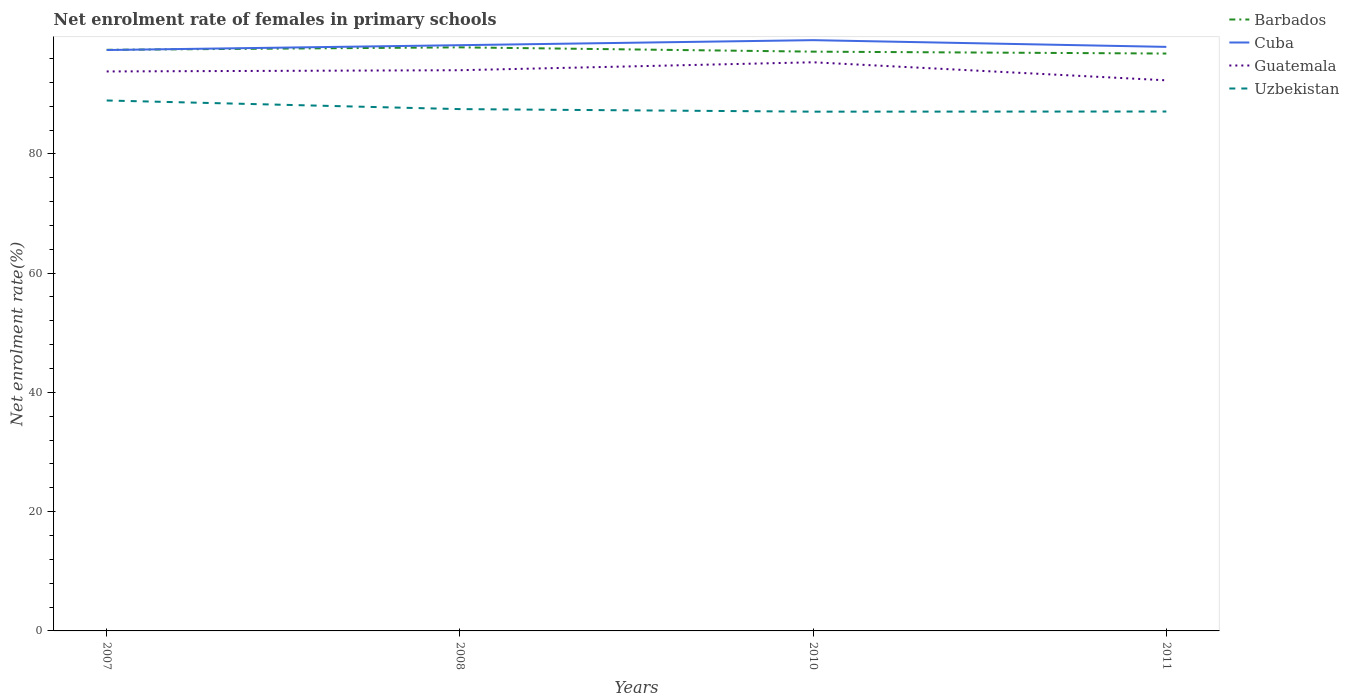Is the number of lines equal to the number of legend labels?
Your answer should be very brief. Yes. Across all years, what is the maximum net enrolment rate of females in primary schools in Cuba?
Provide a succinct answer. 97.42. What is the total net enrolment rate of females in primary schools in Guatemala in the graph?
Keep it short and to the point. -1.54. What is the difference between the highest and the second highest net enrolment rate of females in primary schools in Uzbekistan?
Make the answer very short. 1.87. What is the difference between the highest and the lowest net enrolment rate of females in primary schools in Cuba?
Offer a terse response. 2. Are the values on the major ticks of Y-axis written in scientific E-notation?
Your answer should be compact. No. Does the graph contain any zero values?
Give a very brief answer. No. Where does the legend appear in the graph?
Your response must be concise. Top right. What is the title of the graph?
Your answer should be very brief. Net enrolment rate of females in primary schools. Does "United Arab Emirates" appear as one of the legend labels in the graph?
Your response must be concise. No. What is the label or title of the X-axis?
Your response must be concise. Years. What is the label or title of the Y-axis?
Your answer should be very brief. Net enrolment rate(%). What is the Net enrolment rate(%) in Barbados in 2007?
Ensure brevity in your answer.  97.45. What is the Net enrolment rate(%) of Cuba in 2007?
Keep it short and to the point. 97.42. What is the Net enrolment rate(%) of Guatemala in 2007?
Your answer should be very brief. 93.82. What is the Net enrolment rate(%) of Uzbekistan in 2007?
Provide a short and direct response. 88.96. What is the Net enrolment rate(%) of Barbados in 2008?
Your answer should be very brief. 97.87. What is the Net enrolment rate(%) of Cuba in 2008?
Offer a terse response. 98.23. What is the Net enrolment rate(%) of Guatemala in 2008?
Your answer should be compact. 94.03. What is the Net enrolment rate(%) of Uzbekistan in 2008?
Your response must be concise. 87.51. What is the Net enrolment rate(%) of Barbados in 2010?
Ensure brevity in your answer.  97.14. What is the Net enrolment rate(%) in Cuba in 2010?
Your answer should be compact. 99.07. What is the Net enrolment rate(%) in Guatemala in 2010?
Provide a succinct answer. 95.36. What is the Net enrolment rate(%) of Uzbekistan in 2010?
Keep it short and to the point. 87.08. What is the Net enrolment rate(%) of Barbados in 2011?
Your response must be concise. 96.83. What is the Net enrolment rate(%) of Cuba in 2011?
Your answer should be compact. 97.94. What is the Net enrolment rate(%) in Guatemala in 2011?
Your answer should be compact. 92.34. What is the Net enrolment rate(%) of Uzbekistan in 2011?
Make the answer very short. 87.11. Across all years, what is the maximum Net enrolment rate(%) in Barbados?
Provide a short and direct response. 97.87. Across all years, what is the maximum Net enrolment rate(%) of Cuba?
Provide a short and direct response. 99.07. Across all years, what is the maximum Net enrolment rate(%) of Guatemala?
Your answer should be compact. 95.36. Across all years, what is the maximum Net enrolment rate(%) of Uzbekistan?
Provide a short and direct response. 88.96. Across all years, what is the minimum Net enrolment rate(%) of Barbados?
Your answer should be very brief. 96.83. Across all years, what is the minimum Net enrolment rate(%) of Cuba?
Offer a very short reply. 97.42. Across all years, what is the minimum Net enrolment rate(%) of Guatemala?
Keep it short and to the point. 92.34. Across all years, what is the minimum Net enrolment rate(%) in Uzbekistan?
Keep it short and to the point. 87.08. What is the total Net enrolment rate(%) of Barbados in the graph?
Ensure brevity in your answer.  389.29. What is the total Net enrolment rate(%) of Cuba in the graph?
Your answer should be very brief. 392.66. What is the total Net enrolment rate(%) in Guatemala in the graph?
Give a very brief answer. 375.55. What is the total Net enrolment rate(%) of Uzbekistan in the graph?
Your response must be concise. 350.65. What is the difference between the Net enrolment rate(%) in Barbados in 2007 and that in 2008?
Offer a very short reply. -0.41. What is the difference between the Net enrolment rate(%) of Cuba in 2007 and that in 2008?
Your answer should be compact. -0.81. What is the difference between the Net enrolment rate(%) of Guatemala in 2007 and that in 2008?
Your answer should be very brief. -0.21. What is the difference between the Net enrolment rate(%) in Uzbekistan in 2007 and that in 2008?
Give a very brief answer. 1.45. What is the difference between the Net enrolment rate(%) in Barbados in 2007 and that in 2010?
Make the answer very short. 0.31. What is the difference between the Net enrolment rate(%) in Cuba in 2007 and that in 2010?
Your answer should be very brief. -1.66. What is the difference between the Net enrolment rate(%) in Guatemala in 2007 and that in 2010?
Offer a terse response. -1.54. What is the difference between the Net enrolment rate(%) in Uzbekistan in 2007 and that in 2010?
Your answer should be very brief. 1.87. What is the difference between the Net enrolment rate(%) in Barbados in 2007 and that in 2011?
Make the answer very short. 0.63. What is the difference between the Net enrolment rate(%) of Cuba in 2007 and that in 2011?
Ensure brevity in your answer.  -0.53. What is the difference between the Net enrolment rate(%) of Guatemala in 2007 and that in 2011?
Your answer should be compact. 1.49. What is the difference between the Net enrolment rate(%) of Uzbekistan in 2007 and that in 2011?
Your answer should be compact. 1.85. What is the difference between the Net enrolment rate(%) in Barbados in 2008 and that in 2010?
Offer a terse response. 0.72. What is the difference between the Net enrolment rate(%) in Cuba in 2008 and that in 2010?
Your answer should be very brief. -0.84. What is the difference between the Net enrolment rate(%) in Guatemala in 2008 and that in 2010?
Your response must be concise. -1.33. What is the difference between the Net enrolment rate(%) of Uzbekistan in 2008 and that in 2010?
Provide a succinct answer. 0.43. What is the difference between the Net enrolment rate(%) in Barbados in 2008 and that in 2011?
Offer a terse response. 1.04. What is the difference between the Net enrolment rate(%) of Cuba in 2008 and that in 2011?
Make the answer very short. 0.28. What is the difference between the Net enrolment rate(%) in Guatemala in 2008 and that in 2011?
Your answer should be very brief. 1.69. What is the difference between the Net enrolment rate(%) of Uzbekistan in 2008 and that in 2011?
Your answer should be very brief. 0.4. What is the difference between the Net enrolment rate(%) in Barbados in 2010 and that in 2011?
Make the answer very short. 0.32. What is the difference between the Net enrolment rate(%) of Cuba in 2010 and that in 2011?
Make the answer very short. 1.13. What is the difference between the Net enrolment rate(%) of Guatemala in 2010 and that in 2011?
Provide a succinct answer. 3.03. What is the difference between the Net enrolment rate(%) of Uzbekistan in 2010 and that in 2011?
Provide a succinct answer. -0.02. What is the difference between the Net enrolment rate(%) in Barbados in 2007 and the Net enrolment rate(%) in Cuba in 2008?
Provide a short and direct response. -0.78. What is the difference between the Net enrolment rate(%) of Barbados in 2007 and the Net enrolment rate(%) of Guatemala in 2008?
Keep it short and to the point. 3.42. What is the difference between the Net enrolment rate(%) in Barbados in 2007 and the Net enrolment rate(%) in Uzbekistan in 2008?
Ensure brevity in your answer.  9.94. What is the difference between the Net enrolment rate(%) in Cuba in 2007 and the Net enrolment rate(%) in Guatemala in 2008?
Give a very brief answer. 3.38. What is the difference between the Net enrolment rate(%) of Cuba in 2007 and the Net enrolment rate(%) of Uzbekistan in 2008?
Your answer should be compact. 9.91. What is the difference between the Net enrolment rate(%) of Guatemala in 2007 and the Net enrolment rate(%) of Uzbekistan in 2008?
Offer a very short reply. 6.32. What is the difference between the Net enrolment rate(%) of Barbados in 2007 and the Net enrolment rate(%) of Cuba in 2010?
Give a very brief answer. -1.62. What is the difference between the Net enrolment rate(%) in Barbados in 2007 and the Net enrolment rate(%) in Guatemala in 2010?
Your answer should be very brief. 2.09. What is the difference between the Net enrolment rate(%) of Barbados in 2007 and the Net enrolment rate(%) of Uzbekistan in 2010?
Ensure brevity in your answer.  10.37. What is the difference between the Net enrolment rate(%) of Cuba in 2007 and the Net enrolment rate(%) of Guatemala in 2010?
Your answer should be very brief. 2.05. What is the difference between the Net enrolment rate(%) in Cuba in 2007 and the Net enrolment rate(%) in Uzbekistan in 2010?
Your answer should be very brief. 10.33. What is the difference between the Net enrolment rate(%) of Guatemala in 2007 and the Net enrolment rate(%) of Uzbekistan in 2010?
Give a very brief answer. 6.74. What is the difference between the Net enrolment rate(%) in Barbados in 2007 and the Net enrolment rate(%) in Cuba in 2011?
Provide a short and direct response. -0.49. What is the difference between the Net enrolment rate(%) in Barbados in 2007 and the Net enrolment rate(%) in Guatemala in 2011?
Offer a very short reply. 5.12. What is the difference between the Net enrolment rate(%) in Barbados in 2007 and the Net enrolment rate(%) in Uzbekistan in 2011?
Provide a short and direct response. 10.35. What is the difference between the Net enrolment rate(%) of Cuba in 2007 and the Net enrolment rate(%) of Guatemala in 2011?
Offer a terse response. 5.08. What is the difference between the Net enrolment rate(%) of Cuba in 2007 and the Net enrolment rate(%) of Uzbekistan in 2011?
Provide a succinct answer. 10.31. What is the difference between the Net enrolment rate(%) of Guatemala in 2007 and the Net enrolment rate(%) of Uzbekistan in 2011?
Offer a very short reply. 6.72. What is the difference between the Net enrolment rate(%) in Barbados in 2008 and the Net enrolment rate(%) in Cuba in 2010?
Keep it short and to the point. -1.21. What is the difference between the Net enrolment rate(%) of Barbados in 2008 and the Net enrolment rate(%) of Guatemala in 2010?
Keep it short and to the point. 2.5. What is the difference between the Net enrolment rate(%) in Barbados in 2008 and the Net enrolment rate(%) in Uzbekistan in 2010?
Ensure brevity in your answer.  10.78. What is the difference between the Net enrolment rate(%) of Cuba in 2008 and the Net enrolment rate(%) of Guatemala in 2010?
Your response must be concise. 2.87. What is the difference between the Net enrolment rate(%) of Cuba in 2008 and the Net enrolment rate(%) of Uzbekistan in 2010?
Keep it short and to the point. 11.15. What is the difference between the Net enrolment rate(%) of Guatemala in 2008 and the Net enrolment rate(%) of Uzbekistan in 2010?
Offer a terse response. 6.95. What is the difference between the Net enrolment rate(%) of Barbados in 2008 and the Net enrolment rate(%) of Cuba in 2011?
Give a very brief answer. -0.08. What is the difference between the Net enrolment rate(%) of Barbados in 2008 and the Net enrolment rate(%) of Guatemala in 2011?
Give a very brief answer. 5.53. What is the difference between the Net enrolment rate(%) in Barbados in 2008 and the Net enrolment rate(%) in Uzbekistan in 2011?
Provide a short and direct response. 10.76. What is the difference between the Net enrolment rate(%) of Cuba in 2008 and the Net enrolment rate(%) of Guatemala in 2011?
Offer a terse response. 5.89. What is the difference between the Net enrolment rate(%) of Cuba in 2008 and the Net enrolment rate(%) of Uzbekistan in 2011?
Keep it short and to the point. 11.12. What is the difference between the Net enrolment rate(%) of Guatemala in 2008 and the Net enrolment rate(%) of Uzbekistan in 2011?
Give a very brief answer. 6.92. What is the difference between the Net enrolment rate(%) of Barbados in 2010 and the Net enrolment rate(%) of Guatemala in 2011?
Offer a very short reply. 4.81. What is the difference between the Net enrolment rate(%) of Barbados in 2010 and the Net enrolment rate(%) of Uzbekistan in 2011?
Offer a very short reply. 10.04. What is the difference between the Net enrolment rate(%) in Cuba in 2010 and the Net enrolment rate(%) in Guatemala in 2011?
Provide a short and direct response. 6.74. What is the difference between the Net enrolment rate(%) in Cuba in 2010 and the Net enrolment rate(%) in Uzbekistan in 2011?
Provide a short and direct response. 11.97. What is the difference between the Net enrolment rate(%) of Guatemala in 2010 and the Net enrolment rate(%) of Uzbekistan in 2011?
Offer a terse response. 8.26. What is the average Net enrolment rate(%) of Barbados per year?
Ensure brevity in your answer.  97.32. What is the average Net enrolment rate(%) in Cuba per year?
Your answer should be compact. 98.17. What is the average Net enrolment rate(%) in Guatemala per year?
Provide a short and direct response. 93.89. What is the average Net enrolment rate(%) in Uzbekistan per year?
Your answer should be very brief. 87.66. In the year 2007, what is the difference between the Net enrolment rate(%) in Barbados and Net enrolment rate(%) in Cuba?
Make the answer very short. 0.04. In the year 2007, what is the difference between the Net enrolment rate(%) of Barbados and Net enrolment rate(%) of Guatemala?
Offer a terse response. 3.63. In the year 2007, what is the difference between the Net enrolment rate(%) of Barbados and Net enrolment rate(%) of Uzbekistan?
Your response must be concise. 8.5. In the year 2007, what is the difference between the Net enrolment rate(%) in Cuba and Net enrolment rate(%) in Guatemala?
Give a very brief answer. 3.59. In the year 2007, what is the difference between the Net enrolment rate(%) in Cuba and Net enrolment rate(%) in Uzbekistan?
Provide a succinct answer. 8.46. In the year 2007, what is the difference between the Net enrolment rate(%) of Guatemala and Net enrolment rate(%) of Uzbekistan?
Make the answer very short. 4.87. In the year 2008, what is the difference between the Net enrolment rate(%) of Barbados and Net enrolment rate(%) of Cuba?
Provide a short and direct response. -0.36. In the year 2008, what is the difference between the Net enrolment rate(%) of Barbados and Net enrolment rate(%) of Guatemala?
Offer a terse response. 3.83. In the year 2008, what is the difference between the Net enrolment rate(%) of Barbados and Net enrolment rate(%) of Uzbekistan?
Give a very brief answer. 10.36. In the year 2008, what is the difference between the Net enrolment rate(%) in Cuba and Net enrolment rate(%) in Guatemala?
Provide a short and direct response. 4.2. In the year 2008, what is the difference between the Net enrolment rate(%) of Cuba and Net enrolment rate(%) of Uzbekistan?
Give a very brief answer. 10.72. In the year 2008, what is the difference between the Net enrolment rate(%) of Guatemala and Net enrolment rate(%) of Uzbekistan?
Your answer should be very brief. 6.52. In the year 2010, what is the difference between the Net enrolment rate(%) in Barbados and Net enrolment rate(%) in Cuba?
Keep it short and to the point. -1.93. In the year 2010, what is the difference between the Net enrolment rate(%) in Barbados and Net enrolment rate(%) in Guatemala?
Your answer should be compact. 1.78. In the year 2010, what is the difference between the Net enrolment rate(%) of Barbados and Net enrolment rate(%) of Uzbekistan?
Provide a succinct answer. 10.06. In the year 2010, what is the difference between the Net enrolment rate(%) of Cuba and Net enrolment rate(%) of Guatemala?
Ensure brevity in your answer.  3.71. In the year 2010, what is the difference between the Net enrolment rate(%) of Cuba and Net enrolment rate(%) of Uzbekistan?
Provide a short and direct response. 11.99. In the year 2010, what is the difference between the Net enrolment rate(%) in Guatemala and Net enrolment rate(%) in Uzbekistan?
Keep it short and to the point. 8.28. In the year 2011, what is the difference between the Net enrolment rate(%) of Barbados and Net enrolment rate(%) of Cuba?
Make the answer very short. -1.12. In the year 2011, what is the difference between the Net enrolment rate(%) of Barbados and Net enrolment rate(%) of Guatemala?
Offer a terse response. 4.49. In the year 2011, what is the difference between the Net enrolment rate(%) of Barbados and Net enrolment rate(%) of Uzbekistan?
Give a very brief answer. 9.72. In the year 2011, what is the difference between the Net enrolment rate(%) of Cuba and Net enrolment rate(%) of Guatemala?
Keep it short and to the point. 5.61. In the year 2011, what is the difference between the Net enrolment rate(%) of Cuba and Net enrolment rate(%) of Uzbekistan?
Provide a succinct answer. 10.84. In the year 2011, what is the difference between the Net enrolment rate(%) of Guatemala and Net enrolment rate(%) of Uzbekistan?
Offer a very short reply. 5.23. What is the ratio of the Net enrolment rate(%) of Cuba in 2007 to that in 2008?
Give a very brief answer. 0.99. What is the ratio of the Net enrolment rate(%) of Guatemala in 2007 to that in 2008?
Your response must be concise. 1. What is the ratio of the Net enrolment rate(%) in Uzbekistan in 2007 to that in 2008?
Ensure brevity in your answer.  1.02. What is the ratio of the Net enrolment rate(%) of Barbados in 2007 to that in 2010?
Your answer should be very brief. 1. What is the ratio of the Net enrolment rate(%) in Cuba in 2007 to that in 2010?
Ensure brevity in your answer.  0.98. What is the ratio of the Net enrolment rate(%) in Guatemala in 2007 to that in 2010?
Ensure brevity in your answer.  0.98. What is the ratio of the Net enrolment rate(%) of Uzbekistan in 2007 to that in 2010?
Provide a short and direct response. 1.02. What is the ratio of the Net enrolment rate(%) of Barbados in 2007 to that in 2011?
Make the answer very short. 1.01. What is the ratio of the Net enrolment rate(%) of Guatemala in 2007 to that in 2011?
Offer a very short reply. 1.02. What is the ratio of the Net enrolment rate(%) in Uzbekistan in 2007 to that in 2011?
Offer a very short reply. 1.02. What is the ratio of the Net enrolment rate(%) in Barbados in 2008 to that in 2010?
Your response must be concise. 1.01. What is the ratio of the Net enrolment rate(%) of Barbados in 2008 to that in 2011?
Your response must be concise. 1.01. What is the ratio of the Net enrolment rate(%) in Guatemala in 2008 to that in 2011?
Provide a short and direct response. 1.02. What is the ratio of the Net enrolment rate(%) of Cuba in 2010 to that in 2011?
Your answer should be very brief. 1.01. What is the ratio of the Net enrolment rate(%) of Guatemala in 2010 to that in 2011?
Provide a succinct answer. 1.03. What is the ratio of the Net enrolment rate(%) of Uzbekistan in 2010 to that in 2011?
Provide a short and direct response. 1. What is the difference between the highest and the second highest Net enrolment rate(%) in Barbados?
Provide a short and direct response. 0.41. What is the difference between the highest and the second highest Net enrolment rate(%) in Cuba?
Your answer should be very brief. 0.84. What is the difference between the highest and the second highest Net enrolment rate(%) in Guatemala?
Your answer should be very brief. 1.33. What is the difference between the highest and the second highest Net enrolment rate(%) in Uzbekistan?
Make the answer very short. 1.45. What is the difference between the highest and the lowest Net enrolment rate(%) in Barbados?
Provide a short and direct response. 1.04. What is the difference between the highest and the lowest Net enrolment rate(%) in Cuba?
Give a very brief answer. 1.66. What is the difference between the highest and the lowest Net enrolment rate(%) of Guatemala?
Offer a terse response. 3.03. What is the difference between the highest and the lowest Net enrolment rate(%) of Uzbekistan?
Provide a succinct answer. 1.87. 